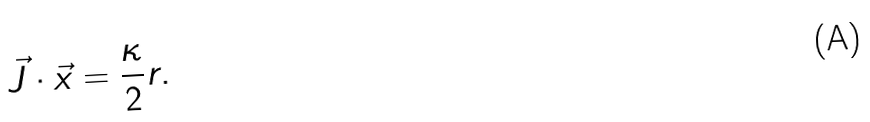Convert formula to latex. <formula><loc_0><loc_0><loc_500><loc_500>\vec { J } \cdot \vec { x } = \frac { \kappa } { 2 } r .</formula> 